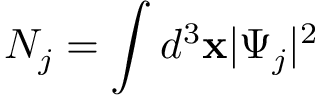<formula> <loc_0><loc_0><loc_500><loc_500>N _ { j } = \int d ^ { 3 } x | \Psi _ { j } | ^ { 2 }</formula> 